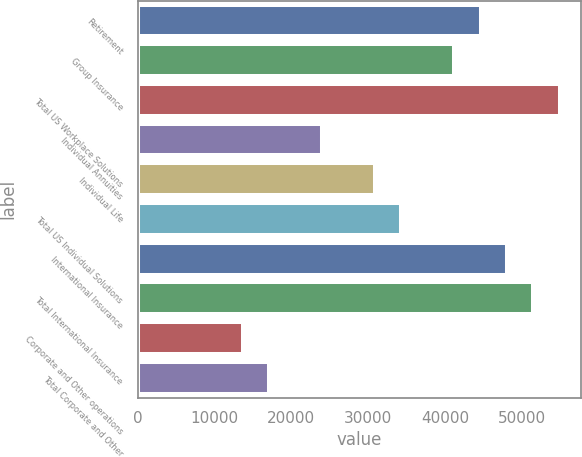Convert chart. <chart><loc_0><loc_0><loc_500><loc_500><bar_chart><fcel>Retirement<fcel>Group Insurance<fcel>Total US Workplace Solutions<fcel>Individual Annuities<fcel>Individual Life<fcel>Total US Individual Solutions<fcel>International Insurance<fcel>Total International Insurance<fcel>Corporate and Other operations<fcel>Total Corporate and Other<nl><fcel>44604.5<fcel>41173.7<fcel>54897<fcel>24019.5<fcel>30881.2<fcel>34312<fcel>48035.3<fcel>51466.1<fcel>13727<fcel>17157.8<nl></chart> 